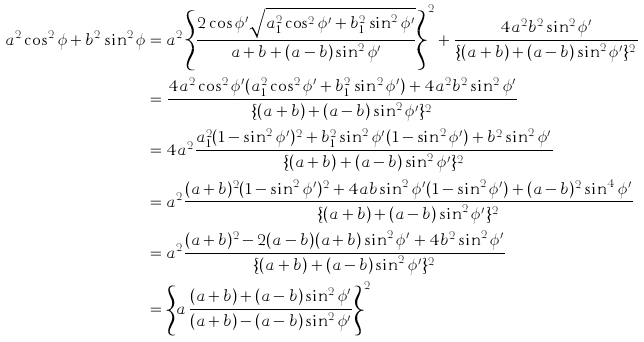<formula> <loc_0><loc_0><loc_500><loc_500>a ^ { 2 } \cos ^ { 2 } \phi + b ^ { 2 } \sin ^ { 2 } \phi & = a ^ { 2 } \left \{ \frac { 2 \cos \phi ^ { \prime } \sqrt { a _ { 1 } ^ { 2 } \cos ^ { 2 } \phi ^ { \prime } + b _ { 1 } ^ { 2 } \sin ^ { 2 } \phi ^ { \prime } } } { a + b + ( a - b ) \sin ^ { 2 } \phi ^ { \prime } } \right \} ^ { 2 } + \frac { 4 a ^ { 2 } b ^ { 2 } \sin ^ { 2 } \phi ^ { \prime } } { \{ ( a + b ) + ( a - b ) \sin ^ { 2 } \phi ^ { \prime } \} ^ { 2 } } \\ & = \frac { 4 a ^ { 2 } \cos ^ { 2 } \phi ^ { \prime } ( a _ { 1 } ^ { 2 } \cos ^ { 2 } \phi ^ { \prime } + b _ { 1 } ^ { 2 } \sin ^ { 2 } \phi ^ { \prime } ) + 4 a ^ { 2 } b ^ { 2 } \sin ^ { 2 } \phi ^ { \prime } } { \{ ( a + b ) + ( a - b ) \sin ^ { 2 } \phi ^ { \prime } \} ^ { 2 } } \\ & = 4 a ^ { 2 } \frac { a _ { 1 } ^ { 2 } ( 1 - \sin ^ { 2 } \phi ^ { \prime } ) ^ { 2 } + b _ { 1 } ^ { 2 } \sin ^ { 2 } \phi ^ { \prime } ( 1 - \sin ^ { 2 } \phi ^ { \prime } ) + b ^ { 2 } \sin ^ { 2 } \phi ^ { \prime } } { \{ ( a + b ) + ( a - b ) \sin ^ { 2 } \phi ^ { \prime } \} ^ { 2 } } \\ & = a ^ { 2 } \frac { ( a + b ) ^ { 2 } ( 1 - \sin ^ { 2 } \phi ^ { \prime } ) ^ { 2 } + 4 a b \sin ^ { 2 } \phi ^ { \prime } ( 1 - \sin ^ { 2 } \phi ^ { \prime } ) + ( a - b ) ^ { 2 } \sin ^ { 4 } \phi ^ { \prime } } { \{ ( a + b ) + ( a - b ) \sin ^ { 2 } \phi ^ { \prime } \} ^ { 2 } } \\ & = a ^ { 2 } \frac { ( a + b ) ^ { 2 } - 2 ( a - b ) ( a + b ) \sin ^ { 2 } \phi ^ { \prime } + 4 b ^ { 2 } \sin ^ { 2 } \phi ^ { \prime } } { \{ ( a + b ) + ( a - b ) \sin ^ { 2 } \phi ^ { \prime } \} ^ { 2 } } \\ & = \left \{ a \, \frac { ( a + b ) + ( a - b ) \sin ^ { 2 } \phi ^ { \prime } } { ( a + b ) - ( a - b ) \sin ^ { 2 } \phi ^ { \prime } } \right \} ^ { 2 }</formula> 